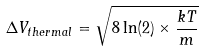<formula> <loc_0><loc_0><loc_500><loc_500>\Delta V _ { t h e r m a l } = \sqrt { 8 \ln ( 2 ) \times \frac { k T } { m } }</formula> 